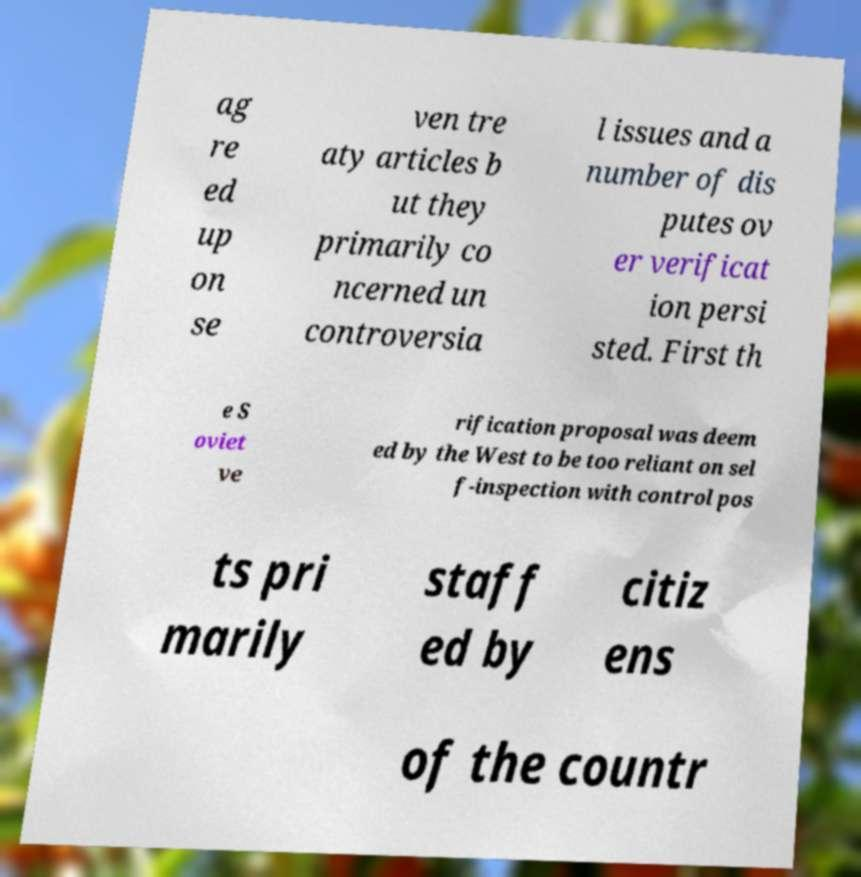For documentation purposes, I need the text within this image transcribed. Could you provide that? ag re ed up on se ven tre aty articles b ut they primarily co ncerned un controversia l issues and a number of dis putes ov er verificat ion persi sted. First th e S oviet ve rification proposal was deem ed by the West to be too reliant on sel f-inspection with control pos ts pri marily staff ed by citiz ens of the countr 